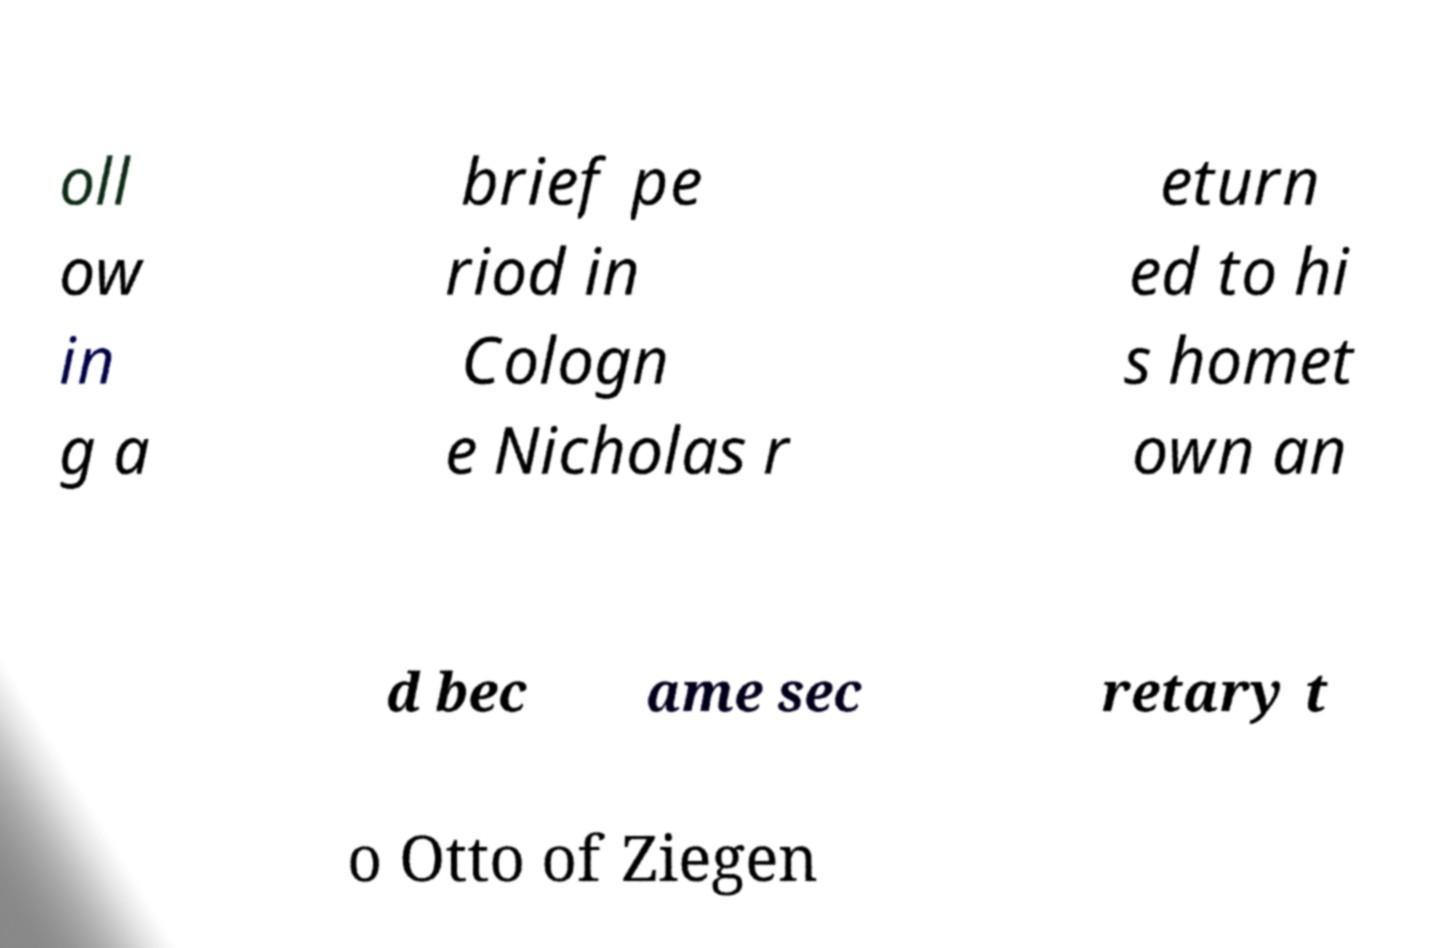I need the written content from this picture converted into text. Can you do that? oll ow in g a brief pe riod in Cologn e Nicholas r eturn ed to hi s homet own an d bec ame sec retary t o Otto of Ziegen 